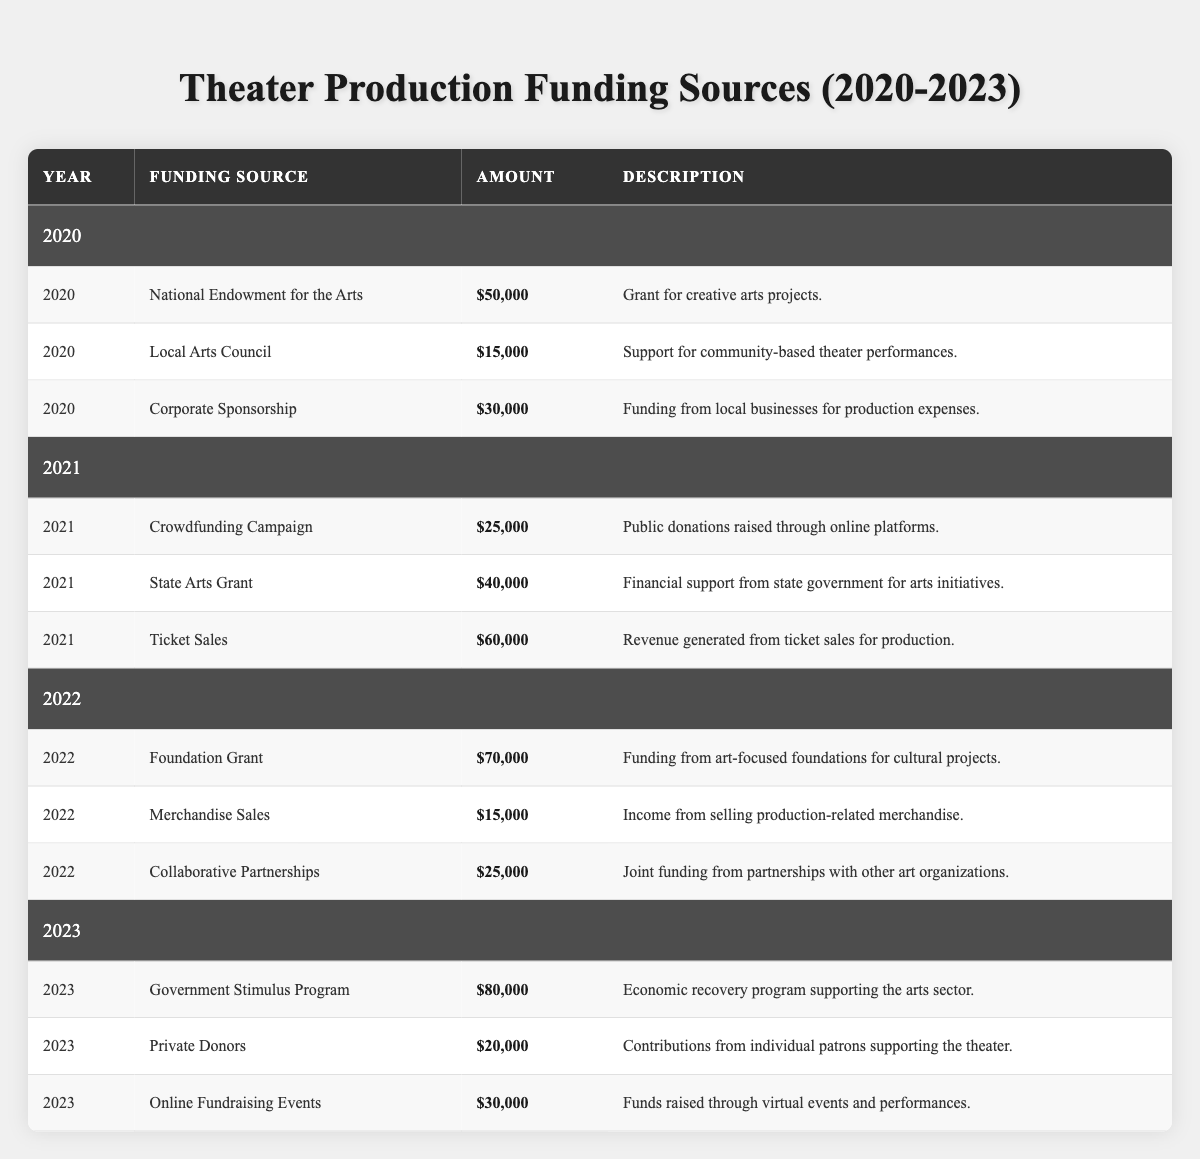What is the total amount of funding received in 2022? For 2022, the funding sources and their amounts are: Foundation Grant ($70,000), Merchandise Sales ($15,000), and Collaborative Partnerships ($25,000). Adding these amounts gives: 70,000 + 15,000 + 25,000 = 110,000.
Answer: $110,000 Which year received the highest amount of funding? The funding for each year is as follows: 2020 ($95,000), 2021 ($125,000), 2022 ($110,000), and 2023 ($130,000). Comparing these totals, the highest amount is in 2023 with $130,000.
Answer: 2023 Is there any funding source that provided more than $50,000 in 2021? Examining the funding sources for 2021: Crowdfunding Campaign ($25,000), State Arts Grant ($40,000), and Ticket Sales ($60,000). Here, Ticket Sales is the only source over $50,000, making the answer yes.
Answer: Yes What was the increase in total funding from 2020 to 2023? The total funding in 2020 was $95,000 and in 2023 it was $130,000. The difference between these two years is calculated as: $130,000 - $95,000 = $35,000.
Answer: $35,000 Which funding source contributed the least amount of funding in 2020? The funding sources for 2020 are National Endowment for the Arts ($50,000), Local Arts Council ($15,000), and Corporate Sponsorship ($30,000). Among these, Local Arts Council has the least amount, which is $15,000.
Answer: $15,000 What is the average amount of funding received per year from 2020 to 2023? The total funding amounts are: 2020 ($95,000), 2021 ($125,000), 2022 ($110,000), and 2023 ($130,000). Summing these gives $460,000. There are 4 years, so the average is $460,000 / 4 = $115,000.
Answer: $115,000 How many funding sources were there in 2021? In 2021, the funding sources listed are: Crowdfunding Campaign, State Arts Grant, and Ticket Sales, which makes a total of 3 funding sources.
Answer: 3 What percentage of the total funding for 2022 came from the Foundation Grant? The total funding for 2022 is $110,000 and the Foundation Grant amount is $70,000. The percentage is calculated as: ($70,000 / $110,000) * 100 = 63.64%.
Answer: 63.64% If we combine the amounts from Online Fundraising Events and Private Donors in 2023, what is the total? The amounts for these sources in 2023 are Online Fundraising Events ($30,000) and Private Donors ($20,000). Adding these amounts gives $30,000 + $20,000 = $50,000.
Answer: $50,000 Was the contribution from Corporate Sponsorship in 2020 greater than the combined contributions from Merchandise Sales and Collaborative Partnerships in 2022? The contribution from Corporate Sponsorship in 2020 is $30,000. The total for Merchandise Sales ($15,000) and Collaborative Partnerships ($25,000) in 2022 is $15,000 + $25,000 = $40,000. Since $30,000 is less than $40,000, the answer is no.
Answer: No What was the total funding received from local sources (Local Arts Council and Corporate Sponsorship) in 2020? The Local Arts Council provided $15,000 and Corporate Sponsorship contributed $30,000 in 2020. Adding these two amounts gives: 15,000 + 30,000 = 45,000.
Answer: $45,000 